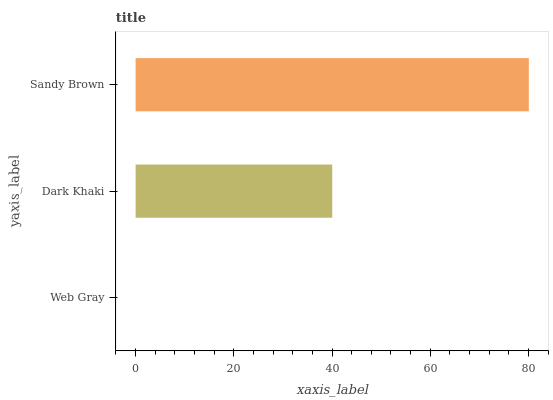Is Web Gray the minimum?
Answer yes or no. Yes. Is Sandy Brown the maximum?
Answer yes or no. Yes. Is Dark Khaki the minimum?
Answer yes or no. No. Is Dark Khaki the maximum?
Answer yes or no. No. Is Dark Khaki greater than Web Gray?
Answer yes or no. Yes. Is Web Gray less than Dark Khaki?
Answer yes or no. Yes. Is Web Gray greater than Dark Khaki?
Answer yes or no. No. Is Dark Khaki less than Web Gray?
Answer yes or no. No. Is Dark Khaki the high median?
Answer yes or no. Yes. Is Dark Khaki the low median?
Answer yes or no. Yes. Is Sandy Brown the high median?
Answer yes or no. No. Is Web Gray the low median?
Answer yes or no. No. 